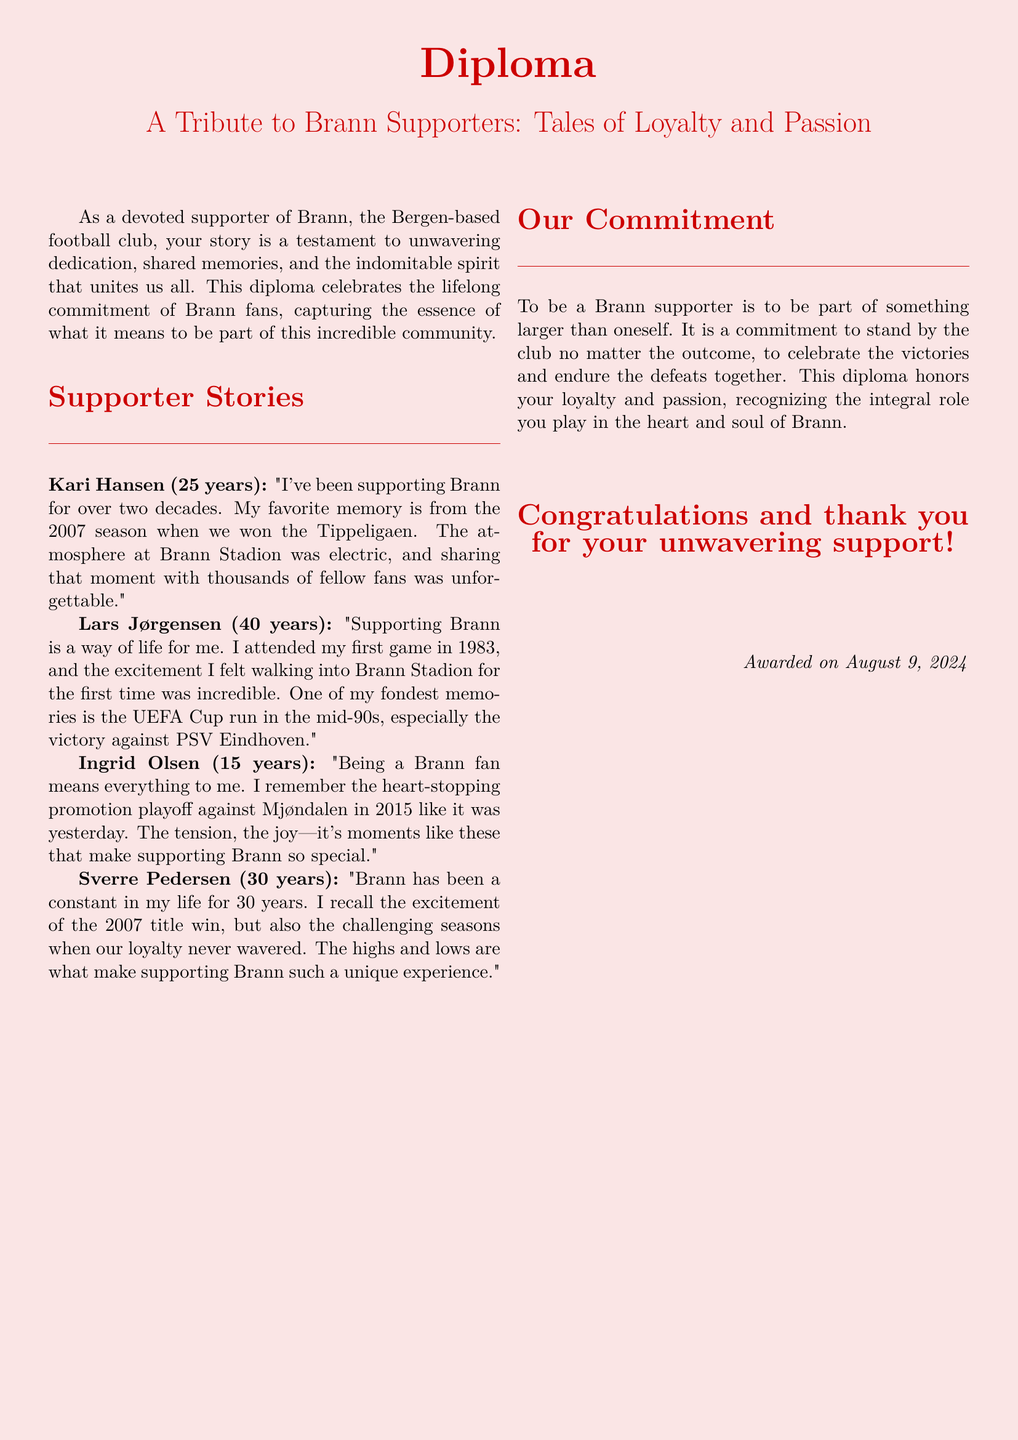What is the title of the diploma? The title of the diploma is highlighted at the top of the document and encapsulates the subject matter.
Answer: A Tribute to Brann Supporters: Tales of Loyalty and Passion Who is the first supporter mentioned in the document? The first supporter story presented in the document belongs to Kari Hansen.
Answer: Kari Hansen How many years has Lars Jørgensen supported Brann? The document states the length of time Lars Jørgensen has supported the club.
Answer: 40 years What significant event is highlighted for Ingrid Olsen? The document describes a memorable game that Ingrid Olsen recalls vividly.
Answer: Promotion playoff against Mjøndalen In what year did Brann win the Tippeligaen, according to Kari Hansen? The document specifies the year that Kari Hansen's favorite memory occurred during the season.
Answer: 2007 How long has Sverre Pedersen been a supporter? The document directly mentions the number of years of support Sverre Pedersen has given to Brann.
Answer: 30 years What is described as a constant in Sverre Pedersen's life? The text indicates that Brann has been an unchanging part of Sverre's experiences.
Answer: Brann What key theme does the diploma highlight for Brann supporters? The overarching message the diploma conveys about being a supporter is articulated within the text.
Answer: Loyalty and passion 